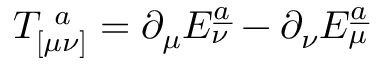Convert formula to latex. <formula><loc_0><loc_0><loc_500><loc_500>T _ { [ \mu \nu ] } ^ { \ a } = \partial _ { \mu } E _ { \nu } ^ { \underline { a } } - \partial _ { \nu } E _ { \mu } ^ { \underline { a } }</formula> 